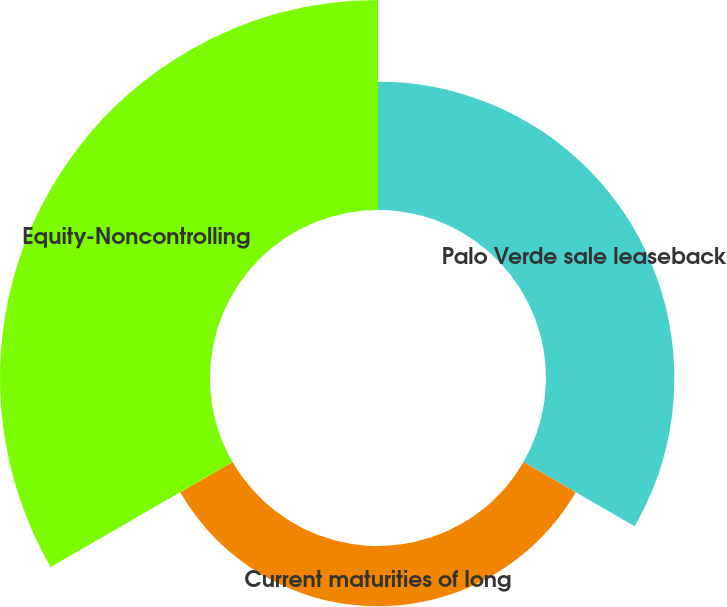Convert chart to OTSL. <chart><loc_0><loc_0><loc_500><loc_500><pie_chart><fcel>Palo Verde sale leaseback<fcel>Current maturities of long<fcel>Equity-Noncontrolling<nl><fcel>32.2%<fcel>15.12%<fcel>52.68%<nl></chart> 